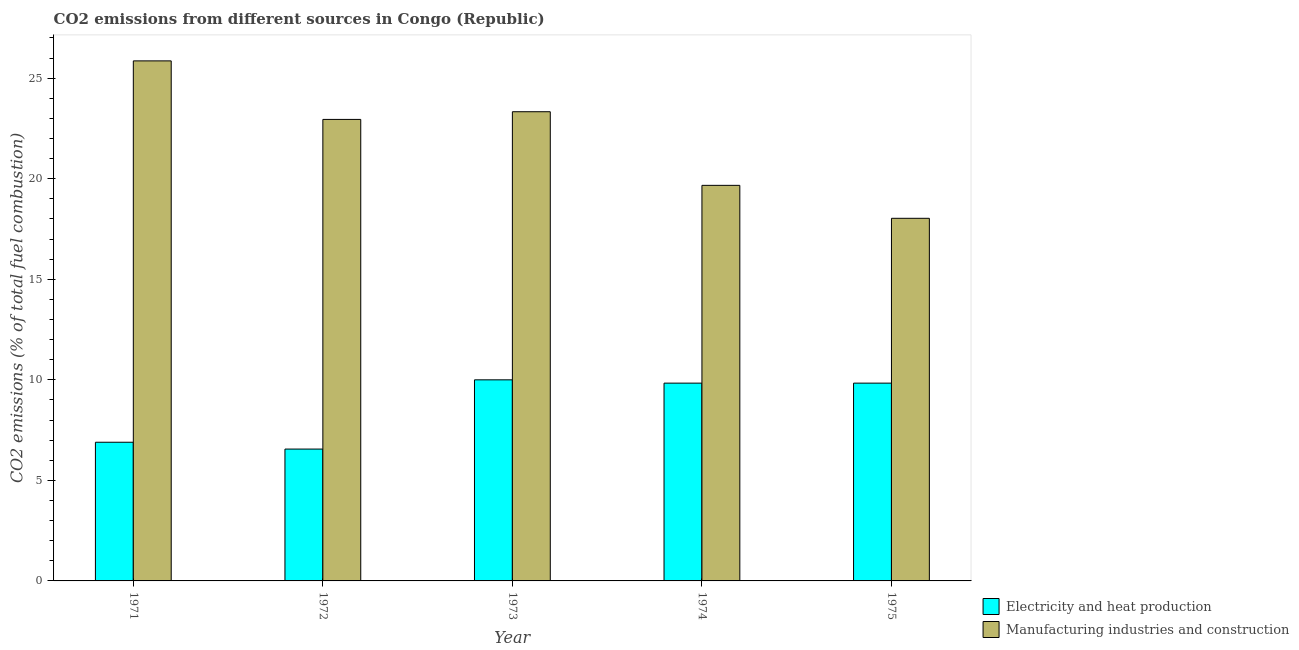How many groups of bars are there?
Offer a very short reply. 5. Are the number of bars per tick equal to the number of legend labels?
Your answer should be very brief. Yes. How many bars are there on the 2nd tick from the left?
Make the answer very short. 2. How many bars are there on the 2nd tick from the right?
Offer a very short reply. 2. What is the label of the 1st group of bars from the left?
Keep it short and to the point. 1971. What is the co2 emissions due to manufacturing industries in 1975?
Provide a short and direct response. 18.03. Across all years, what is the maximum co2 emissions due to manufacturing industries?
Make the answer very short. 25.86. Across all years, what is the minimum co2 emissions due to manufacturing industries?
Give a very brief answer. 18.03. In which year was the co2 emissions due to manufacturing industries minimum?
Your answer should be very brief. 1975. What is the total co2 emissions due to manufacturing industries in the graph?
Ensure brevity in your answer.  109.85. What is the difference between the co2 emissions due to manufacturing industries in 1974 and that in 1975?
Your response must be concise. 1.64. What is the difference between the co2 emissions due to electricity and heat production in 1971 and the co2 emissions due to manufacturing industries in 1974?
Your answer should be very brief. -2.94. What is the average co2 emissions due to manufacturing industries per year?
Offer a terse response. 21.97. In the year 1973, what is the difference between the co2 emissions due to manufacturing industries and co2 emissions due to electricity and heat production?
Your response must be concise. 0. In how many years, is the co2 emissions due to electricity and heat production greater than 14 %?
Your answer should be very brief. 0. What is the ratio of the co2 emissions due to electricity and heat production in 1974 to that in 1975?
Keep it short and to the point. 1. Is the co2 emissions due to manufacturing industries in 1972 less than that in 1973?
Your answer should be compact. Yes. What is the difference between the highest and the second highest co2 emissions due to electricity and heat production?
Offer a very short reply. 0.16. What is the difference between the highest and the lowest co2 emissions due to manufacturing industries?
Offer a very short reply. 7.83. In how many years, is the co2 emissions due to electricity and heat production greater than the average co2 emissions due to electricity and heat production taken over all years?
Your answer should be very brief. 3. Is the sum of the co2 emissions due to manufacturing industries in 1973 and 1975 greater than the maximum co2 emissions due to electricity and heat production across all years?
Give a very brief answer. Yes. What does the 1st bar from the left in 1972 represents?
Your response must be concise. Electricity and heat production. What does the 2nd bar from the right in 1973 represents?
Your answer should be very brief. Electricity and heat production. How many bars are there?
Keep it short and to the point. 10. Are all the bars in the graph horizontal?
Provide a succinct answer. No. How many years are there in the graph?
Ensure brevity in your answer.  5. Are the values on the major ticks of Y-axis written in scientific E-notation?
Give a very brief answer. No. Does the graph contain any zero values?
Keep it short and to the point. No. Does the graph contain grids?
Provide a short and direct response. No. Where does the legend appear in the graph?
Your answer should be compact. Bottom right. What is the title of the graph?
Provide a short and direct response. CO2 emissions from different sources in Congo (Republic). What is the label or title of the Y-axis?
Give a very brief answer. CO2 emissions (% of total fuel combustion). What is the CO2 emissions (% of total fuel combustion) of Electricity and heat production in 1971?
Provide a succinct answer. 6.9. What is the CO2 emissions (% of total fuel combustion) of Manufacturing industries and construction in 1971?
Give a very brief answer. 25.86. What is the CO2 emissions (% of total fuel combustion) in Electricity and heat production in 1972?
Offer a very short reply. 6.56. What is the CO2 emissions (% of total fuel combustion) of Manufacturing industries and construction in 1972?
Offer a terse response. 22.95. What is the CO2 emissions (% of total fuel combustion) in Electricity and heat production in 1973?
Keep it short and to the point. 10. What is the CO2 emissions (% of total fuel combustion) of Manufacturing industries and construction in 1973?
Offer a terse response. 23.33. What is the CO2 emissions (% of total fuel combustion) in Electricity and heat production in 1974?
Your answer should be very brief. 9.84. What is the CO2 emissions (% of total fuel combustion) of Manufacturing industries and construction in 1974?
Offer a very short reply. 19.67. What is the CO2 emissions (% of total fuel combustion) of Electricity and heat production in 1975?
Offer a very short reply. 9.84. What is the CO2 emissions (% of total fuel combustion) of Manufacturing industries and construction in 1975?
Give a very brief answer. 18.03. Across all years, what is the maximum CO2 emissions (% of total fuel combustion) of Electricity and heat production?
Keep it short and to the point. 10. Across all years, what is the maximum CO2 emissions (% of total fuel combustion) in Manufacturing industries and construction?
Provide a succinct answer. 25.86. Across all years, what is the minimum CO2 emissions (% of total fuel combustion) of Electricity and heat production?
Your response must be concise. 6.56. Across all years, what is the minimum CO2 emissions (% of total fuel combustion) in Manufacturing industries and construction?
Your response must be concise. 18.03. What is the total CO2 emissions (% of total fuel combustion) of Electricity and heat production in the graph?
Offer a terse response. 43.13. What is the total CO2 emissions (% of total fuel combustion) of Manufacturing industries and construction in the graph?
Your answer should be very brief. 109.85. What is the difference between the CO2 emissions (% of total fuel combustion) in Electricity and heat production in 1971 and that in 1972?
Provide a succinct answer. 0.34. What is the difference between the CO2 emissions (% of total fuel combustion) of Manufacturing industries and construction in 1971 and that in 1972?
Keep it short and to the point. 2.91. What is the difference between the CO2 emissions (% of total fuel combustion) of Electricity and heat production in 1971 and that in 1973?
Your response must be concise. -3.1. What is the difference between the CO2 emissions (% of total fuel combustion) in Manufacturing industries and construction in 1971 and that in 1973?
Offer a terse response. 2.53. What is the difference between the CO2 emissions (% of total fuel combustion) of Electricity and heat production in 1971 and that in 1974?
Offer a very short reply. -2.94. What is the difference between the CO2 emissions (% of total fuel combustion) in Manufacturing industries and construction in 1971 and that in 1974?
Offer a very short reply. 6.19. What is the difference between the CO2 emissions (% of total fuel combustion) in Electricity and heat production in 1971 and that in 1975?
Your answer should be very brief. -2.94. What is the difference between the CO2 emissions (% of total fuel combustion) in Manufacturing industries and construction in 1971 and that in 1975?
Offer a terse response. 7.83. What is the difference between the CO2 emissions (% of total fuel combustion) in Electricity and heat production in 1972 and that in 1973?
Ensure brevity in your answer.  -3.44. What is the difference between the CO2 emissions (% of total fuel combustion) in Manufacturing industries and construction in 1972 and that in 1973?
Make the answer very short. -0.38. What is the difference between the CO2 emissions (% of total fuel combustion) of Electricity and heat production in 1972 and that in 1974?
Your answer should be very brief. -3.28. What is the difference between the CO2 emissions (% of total fuel combustion) of Manufacturing industries and construction in 1972 and that in 1974?
Ensure brevity in your answer.  3.28. What is the difference between the CO2 emissions (% of total fuel combustion) in Electricity and heat production in 1972 and that in 1975?
Make the answer very short. -3.28. What is the difference between the CO2 emissions (% of total fuel combustion) in Manufacturing industries and construction in 1972 and that in 1975?
Offer a very short reply. 4.92. What is the difference between the CO2 emissions (% of total fuel combustion) of Electricity and heat production in 1973 and that in 1974?
Your answer should be very brief. 0.16. What is the difference between the CO2 emissions (% of total fuel combustion) in Manufacturing industries and construction in 1973 and that in 1974?
Give a very brief answer. 3.66. What is the difference between the CO2 emissions (% of total fuel combustion) of Electricity and heat production in 1973 and that in 1975?
Make the answer very short. 0.16. What is the difference between the CO2 emissions (% of total fuel combustion) in Manufacturing industries and construction in 1973 and that in 1975?
Your answer should be very brief. 5.3. What is the difference between the CO2 emissions (% of total fuel combustion) in Manufacturing industries and construction in 1974 and that in 1975?
Provide a short and direct response. 1.64. What is the difference between the CO2 emissions (% of total fuel combustion) of Electricity and heat production in 1971 and the CO2 emissions (% of total fuel combustion) of Manufacturing industries and construction in 1972?
Your answer should be very brief. -16.05. What is the difference between the CO2 emissions (% of total fuel combustion) of Electricity and heat production in 1971 and the CO2 emissions (% of total fuel combustion) of Manufacturing industries and construction in 1973?
Give a very brief answer. -16.44. What is the difference between the CO2 emissions (% of total fuel combustion) of Electricity and heat production in 1971 and the CO2 emissions (% of total fuel combustion) of Manufacturing industries and construction in 1974?
Give a very brief answer. -12.78. What is the difference between the CO2 emissions (% of total fuel combustion) in Electricity and heat production in 1971 and the CO2 emissions (% of total fuel combustion) in Manufacturing industries and construction in 1975?
Offer a terse response. -11.14. What is the difference between the CO2 emissions (% of total fuel combustion) in Electricity and heat production in 1972 and the CO2 emissions (% of total fuel combustion) in Manufacturing industries and construction in 1973?
Offer a very short reply. -16.78. What is the difference between the CO2 emissions (% of total fuel combustion) of Electricity and heat production in 1972 and the CO2 emissions (% of total fuel combustion) of Manufacturing industries and construction in 1974?
Offer a terse response. -13.11. What is the difference between the CO2 emissions (% of total fuel combustion) of Electricity and heat production in 1972 and the CO2 emissions (% of total fuel combustion) of Manufacturing industries and construction in 1975?
Ensure brevity in your answer.  -11.48. What is the difference between the CO2 emissions (% of total fuel combustion) in Electricity and heat production in 1973 and the CO2 emissions (% of total fuel combustion) in Manufacturing industries and construction in 1974?
Your answer should be very brief. -9.67. What is the difference between the CO2 emissions (% of total fuel combustion) in Electricity and heat production in 1973 and the CO2 emissions (% of total fuel combustion) in Manufacturing industries and construction in 1975?
Provide a short and direct response. -8.03. What is the difference between the CO2 emissions (% of total fuel combustion) of Electricity and heat production in 1974 and the CO2 emissions (% of total fuel combustion) of Manufacturing industries and construction in 1975?
Give a very brief answer. -8.2. What is the average CO2 emissions (% of total fuel combustion) of Electricity and heat production per year?
Make the answer very short. 8.63. What is the average CO2 emissions (% of total fuel combustion) in Manufacturing industries and construction per year?
Provide a succinct answer. 21.97. In the year 1971, what is the difference between the CO2 emissions (% of total fuel combustion) in Electricity and heat production and CO2 emissions (% of total fuel combustion) in Manufacturing industries and construction?
Your answer should be compact. -18.97. In the year 1972, what is the difference between the CO2 emissions (% of total fuel combustion) of Electricity and heat production and CO2 emissions (% of total fuel combustion) of Manufacturing industries and construction?
Keep it short and to the point. -16.39. In the year 1973, what is the difference between the CO2 emissions (% of total fuel combustion) of Electricity and heat production and CO2 emissions (% of total fuel combustion) of Manufacturing industries and construction?
Give a very brief answer. -13.33. In the year 1974, what is the difference between the CO2 emissions (% of total fuel combustion) of Electricity and heat production and CO2 emissions (% of total fuel combustion) of Manufacturing industries and construction?
Ensure brevity in your answer.  -9.84. In the year 1975, what is the difference between the CO2 emissions (% of total fuel combustion) of Electricity and heat production and CO2 emissions (% of total fuel combustion) of Manufacturing industries and construction?
Make the answer very short. -8.2. What is the ratio of the CO2 emissions (% of total fuel combustion) in Electricity and heat production in 1971 to that in 1972?
Keep it short and to the point. 1.05. What is the ratio of the CO2 emissions (% of total fuel combustion) in Manufacturing industries and construction in 1971 to that in 1972?
Your answer should be very brief. 1.13. What is the ratio of the CO2 emissions (% of total fuel combustion) in Electricity and heat production in 1971 to that in 1973?
Your answer should be very brief. 0.69. What is the ratio of the CO2 emissions (% of total fuel combustion) in Manufacturing industries and construction in 1971 to that in 1973?
Provide a short and direct response. 1.11. What is the ratio of the CO2 emissions (% of total fuel combustion) in Electricity and heat production in 1971 to that in 1974?
Ensure brevity in your answer.  0.7. What is the ratio of the CO2 emissions (% of total fuel combustion) in Manufacturing industries and construction in 1971 to that in 1974?
Your response must be concise. 1.31. What is the ratio of the CO2 emissions (% of total fuel combustion) in Electricity and heat production in 1971 to that in 1975?
Provide a succinct answer. 0.7. What is the ratio of the CO2 emissions (% of total fuel combustion) in Manufacturing industries and construction in 1971 to that in 1975?
Offer a very short reply. 1.43. What is the ratio of the CO2 emissions (% of total fuel combustion) in Electricity and heat production in 1972 to that in 1973?
Ensure brevity in your answer.  0.66. What is the ratio of the CO2 emissions (% of total fuel combustion) of Manufacturing industries and construction in 1972 to that in 1973?
Give a very brief answer. 0.98. What is the ratio of the CO2 emissions (% of total fuel combustion) in Manufacturing industries and construction in 1972 to that in 1974?
Your response must be concise. 1.17. What is the ratio of the CO2 emissions (% of total fuel combustion) in Electricity and heat production in 1972 to that in 1975?
Ensure brevity in your answer.  0.67. What is the ratio of the CO2 emissions (% of total fuel combustion) in Manufacturing industries and construction in 1972 to that in 1975?
Your response must be concise. 1.27. What is the ratio of the CO2 emissions (% of total fuel combustion) of Electricity and heat production in 1973 to that in 1974?
Give a very brief answer. 1.02. What is the ratio of the CO2 emissions (% of total fuel combustion) in Manufacturing industries and construction in 1973 to that in 1974?
Provide a short and direct response. 1.19. What is the ratio of the CO2 emissions (% of total fuel combustion) of Electricity and heat production in 1973 to that in 1975?
Your response must be concise. 1.02. What is the ratio of the CO2 emissions (% of total fuel combustion) of Manufacturing industries and construction in 1973 to that in 1975?
Make the answer very short. 1.29. What is the difference between the highest and the second highest CO2 emissions (% of total fuel combustion) of Electricity and heat production?
Offer a terse response. 0.16. What is the difference between the highest and the second highest CO2 emissions (% of total fuel combustion) in Manufacturing industries and construction?
Provide a short and direct response. 2.53. What is the difference between the highest and the lowest CO2 emissions (% of total fuel combustion) of Electricity and heat production?
Provide a short and direct response. 3.44. What is the difference between the highest and the lowest CO2 emissions (% of total fuel combustion) of Manufacturing industries and construction?
Ensure brevity in your answer.  7.83. 